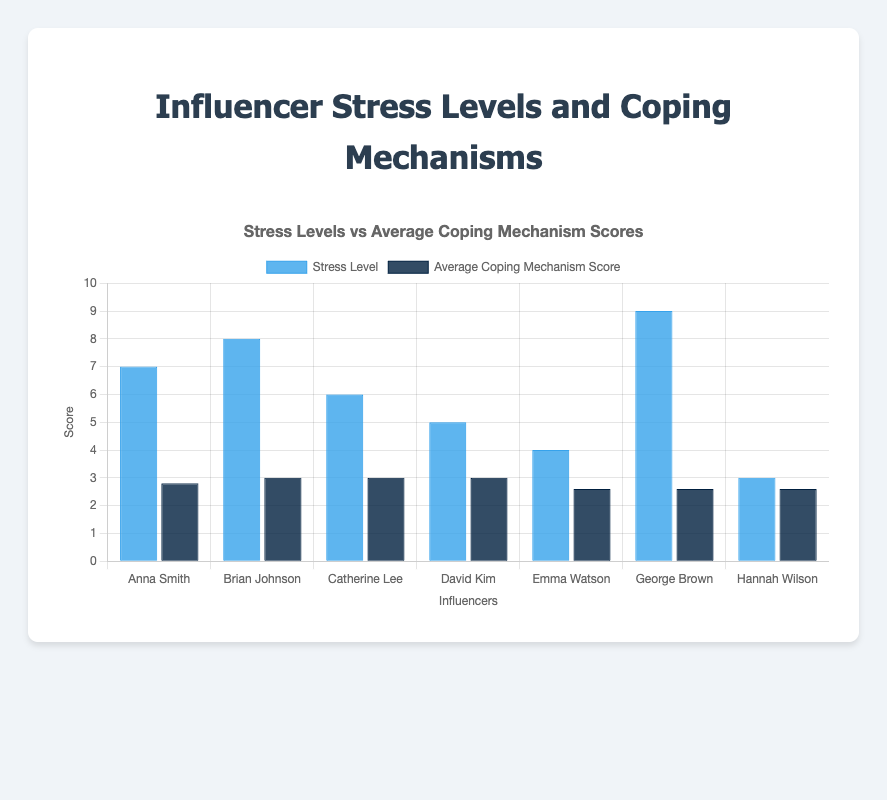Which influencer has the highest self-reported stress level? By looking at the blue bars representing the self-reported stress levels, the tallest bar corresponds to George Brown who has a stress level of 9.
Answer: George Brown Which influencer has the lowest average coping mechanism score? The dark blue bars show the average coping mechanism scores. The shortest dark blue bar belongs to George Brown, indicating he has the lowest average coping mechanism score.
Answer: George Brown What is the difference between Anna Smith's and David Kim's self-reported stress levels? Anna Smith's self-reported stress level is 7, while David Kim's is 5. The difference is 7 - 5, which is 2.
Answer: 2 Compare the average coping mechanism scores of Emma Watson and Brian Johnson. Who employs more coping mechanisms on average? By comparing the dark blue bars for both influencers, Brian Johnson has a higher dark blue bar than Emma Watson, indicating he has higher average coping mechanism scores.
Answer: Brian Johnson What’s the combined stress level of Catherine Lee and Emma Watson? Catherine Lee's stress level is 6, and Emma Watson's is 4. Adding them together gives 6 + 4 = 10.
Answer: 10 Which two influencers have the same self-reported stress levels? By examining the blue bars, both Emma Watson and David Kim have a stress level of 5.
Answer: David Kim and Emma Watson Who has a higher stress level, Catherine Lee or Brian Johnson? Based on the blue bars, Brian Johnson has a stress level of 8, while Catherine Lee has a stress level of 6. Brian Johnson's stress level is higher.
Answer: Brian Johnson What is the average self-reported stress level of all influencers? Summing all self-reported stress levels (7+8+6+5+4+9+3) and dividing by the number of influencers (7) gives (42 / 7) = 6.
Answer: 6 What is the total average coping mechanism score for David Kim? Adding David Kim's coping mechanisms scores: Meditation (4) + Exercise (3) + Social Support (5) + Journaling (3) + Professional Help (0) = 15. The average is 15 / 5 = 3.
Answer: 3 Who reported the second highest stress level among all influencers? Looking at the blue bars, the second tallest bar belongs to Brian Johnson, who has a stress level of 8 (second to George Brown with 9).
Answer: Brian Johnson 